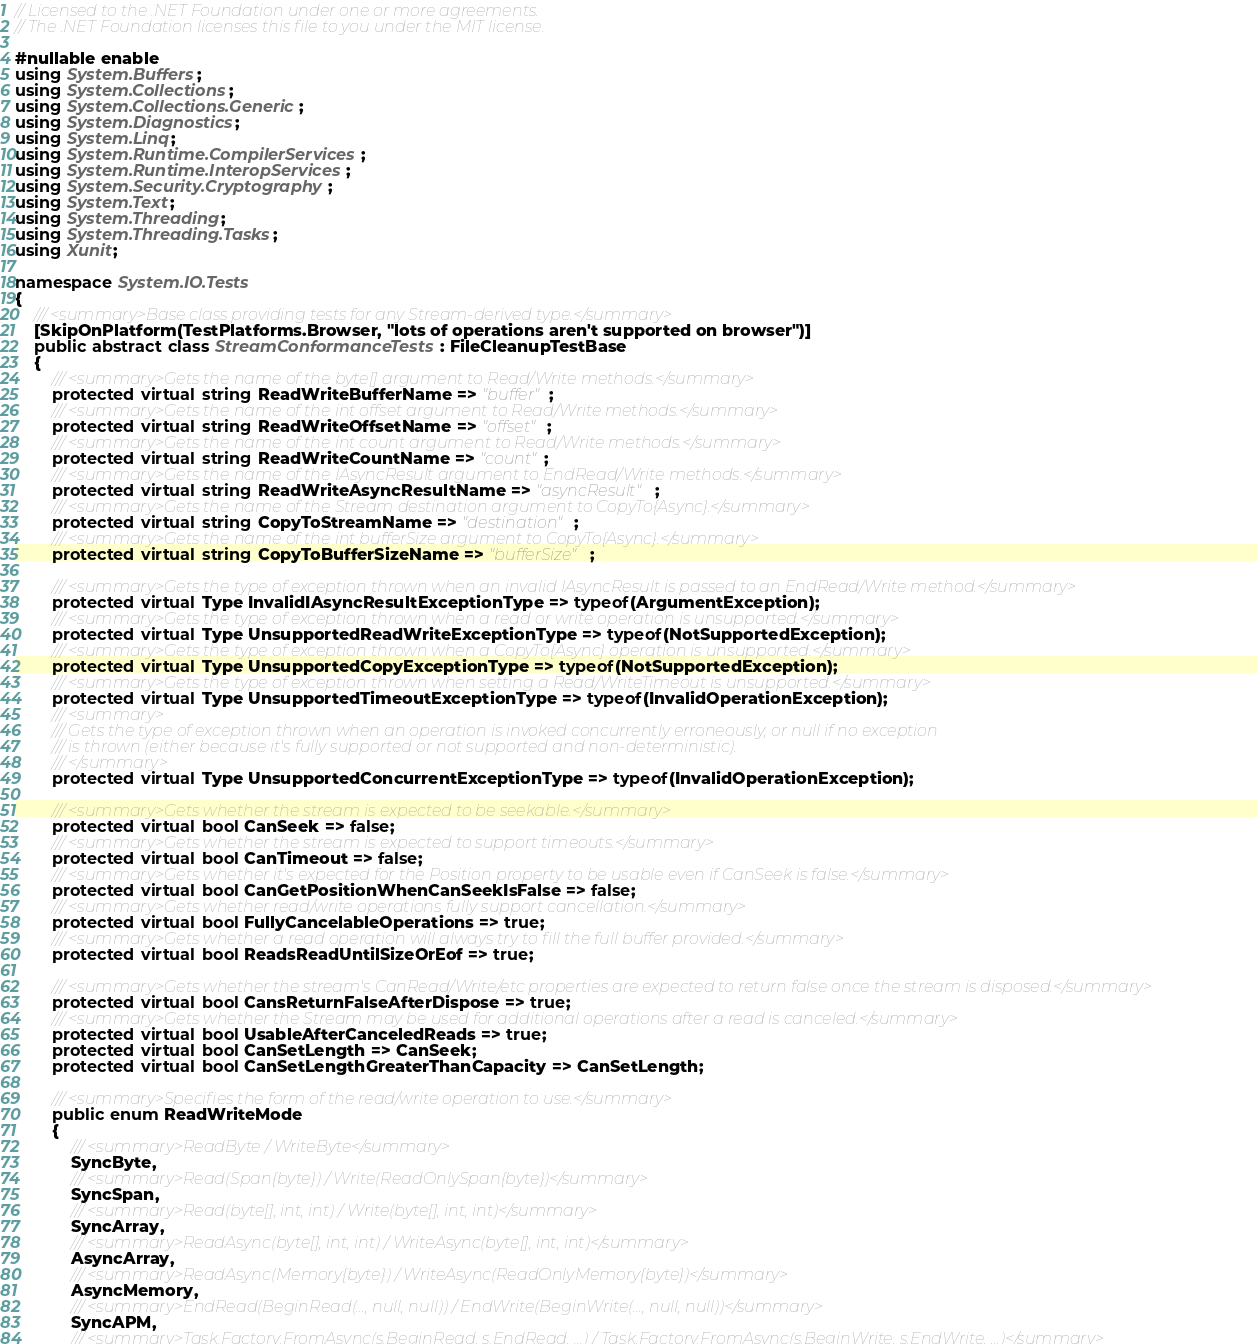<code> <loc_0><loc_0><loc_500><loc_500><_C#_>// Licensed to the .NET Foundation under one or more agreements.
// The .NET Foundation licenses this file to you under the MIT license.

#nullable enable
using System.Buffers;
using System.Collections;
using System.Collections.Generic;
using System.Diagnostics;
using System.Linq;
using System.Runtime.CompilerServices;
using System.Runtime.InteropServices;
using System.Security.Cryptography;
using System.Text;
using System.Threading;
using System.Threading.Tasks;
using Xunit;

namespace System.IO.Tests
{
    /// <summary>Base class providing tests for any Stream-derived type.</summary>
    [SkipOnPlatform(TestPlatforms.Browser, "lots of operations aren't supported on browser")]
    public abstract class StreamConformanceTests : FileCleanupTestBase
    {
        /// <summary>Gets the name of the byte[] argument to Read/Write methods.</summary>
        protected virtual string ReadWriteBufferName => "buffer";
        /// <summary>Gets the name of the int offset argument to Read/Write methods.</summary>
        protected virtual string ReadWriteOffsetName => "offset";
        /// <summary>Gets the name of the int count argument to Read/Write methods.</summary>
        protected virtual string ReadWriteCountName => "count";
        /// <summary>Gets the name of the IAsyncResult argument to EndRead/Write methods.</summary>
        protected virtual string ReadWriteAsyncResultName => "asyncResult";
        /// <summary>Gets the name of the Stream destination argument to CopyTo{Async}.</summary>
        protected virtual string CopyToStreamName => "destination";
        /// <summary>Gets the name of the int bufferSize argument to CopyTo{Async}.</summary>
        protected virtual string CopyToBufferSizeName => "bufferSize";

        /// <summary>Gets the type of exception thrown when an invalid IAsyncResult is passed to an EndRead/Write method.</summary>
        protected virtual Type InvalidIAsyncResultExceptionType => typeof(ArgumentException);
        /// <summary>Gets the type of exception thrown when a read or write operation is unsupported.</summary>
        protected virtual Type UnsupportedReadWriteExceptionType => typeof(NotSupportedException);
        /// <summary>Gets the type of exception thrown when a CopyTo{Async} operation is unsupported.</summary>
        protected virtual Type UnsupportedCopyExceptionType => typeof(NotSupportedException);
        /// <summary>Gets the type of exception thrown when setting a Read/WriteTimeout is unsupported.</summary>
        protected virtual Type UnsupportedTimeoutExceptionType => typeof(InvalidOperationException);
        /// <summary>
        /// Gets the type of exception thrown when an operation is invoked concurrently erroneously, or null if no exception
        /// is thrown (either because it's fully supported or not supported and non-deterministic).
        /// </summary>
        protected virtual Type UnsupportedConcurrentExceptionType => typeof(InvalidOperationException);

        /// <summary>Gets whether the stream is expected to be seekable.</summary>
        protected virtual bool CanSeek => false;
        /// <summary>Gets whether the stream is expected to support timeouts.</summary>
        protected virtual bool CanTimeout => false;
        /// <summary>Gets whether it's expected for the Position property to be usable even if CanSeek is false.</summary>
        protected virtual bool CanGetPositionWhenCanSeekIsFalse => false;
        /// <summary>Gets whether read/write operations fully support cancellation.</summary>
        protected virtual bool FullyCancelableOperations => true;
        /// <summary>Gets whether a read operation will always try to fill the full buffer provided.</summary>
        protected virtual bool ReadsReadUntilSizeOrEof => true;

        /// <summary>Gets whether the stream's CanRead/Write/etc properties are expected to return false once the stream is disposed.</summary>
        protected virtual bool CansReturnFalseAfterDispose => true;
        /// <summary>Gets whether the Stream may be used for additional operations after a read is canceled.</summary>
        protected virtual bool UsableAfterCanceledReads => true;
        protected virtual bool CanSetLength => CanSeek;
        protected virtual bool CanSetLengthGreaterThanCapacity => CanSetLength;

        /// <summary>Specifies the form of the read/write operation to use.</summary>
        public enum ReadWriteMode
        {
            /// <summary>ReadByte / WriteByte</summary>
            SyncByte,
            /// <summary>Read(Span{byte}) / Write(ReadOnlySpan{byte})</summary>
            SyncSpan,
            /// <summary>Read(byte[], int, int) / Write(byte[], int, int)</summary>
            SyncArray,
            /// <summary>ReadAsync(byte[], int, int) / WriteAsync(byte[], int, int)</summary>
            AsyncArray,
            /// <summary>ReadAsync(Memory{byte}) / WriteAsync(ReadOnlyMemory{byte})</summary>
            AsyncMemory,
            /// <summary>EndRead(BeginRead(..., null, null)) / EndWrite(BeginWrite(..., null, null))</summary>
            SyncAPM,
            /// <summary>Task.Factory.FromAsync(s.BeginRead, s.EndRead, ...) / Task.Factory.FromAsync(s.BeginWrite, s.EndWrite, ...)</summary></code> 